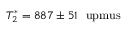Convert formula to latex. <formula><loc_0><loc_0><loc_500><loc_500>T _ { 2 } ^ { \ast } = 8 8 7 \pm 5 1 \ u p m u s</formula> 